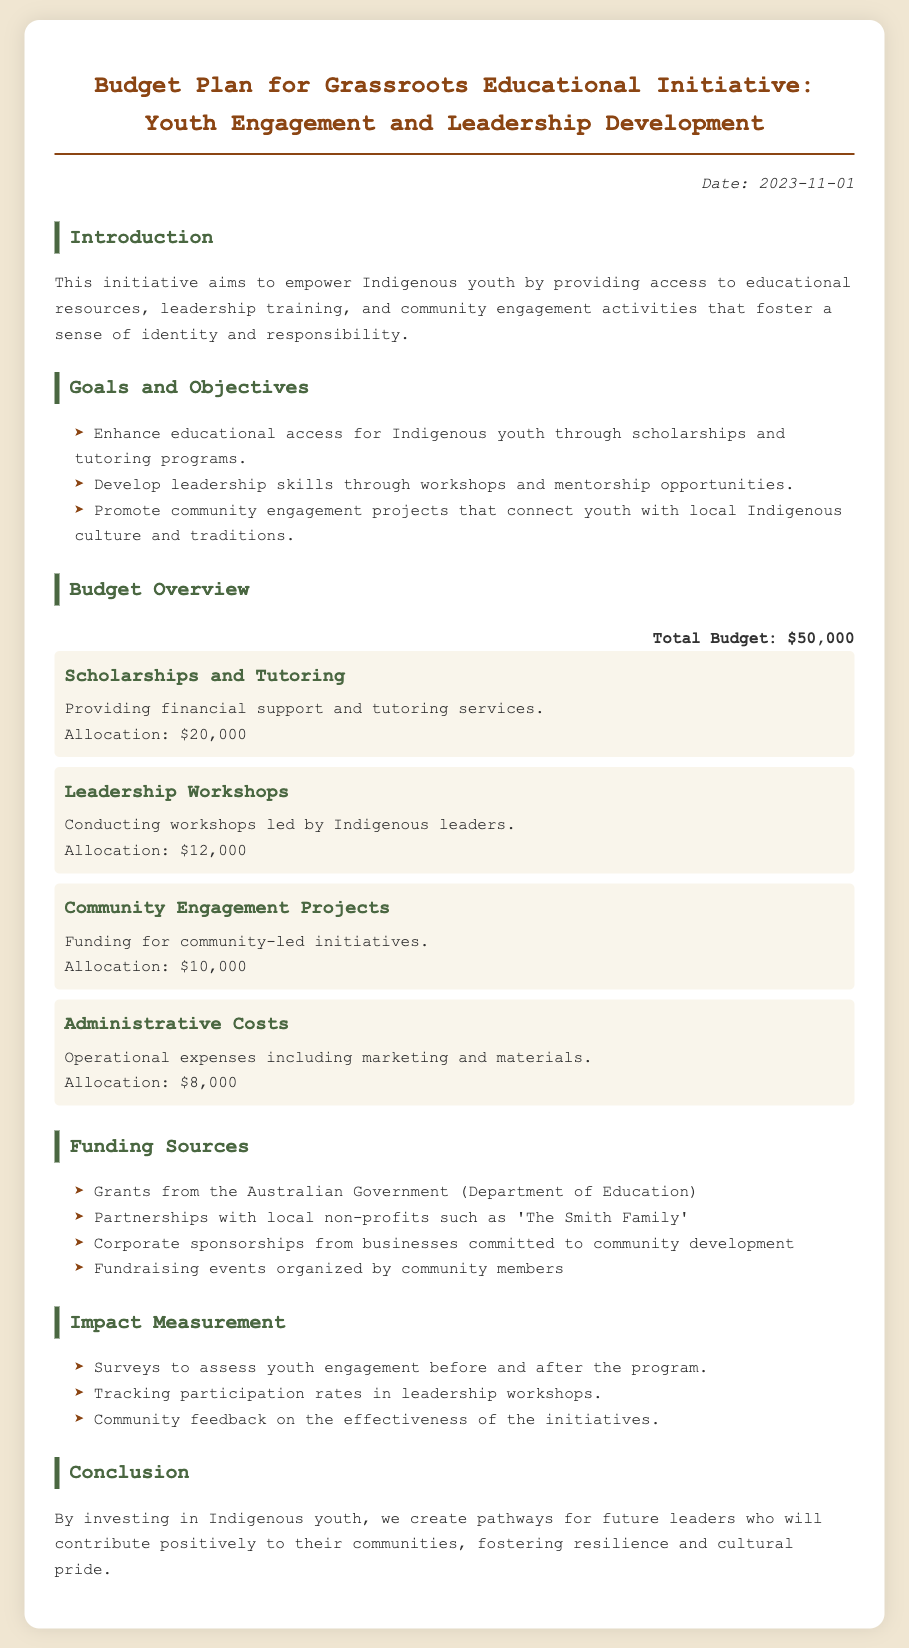What is the total budget for the initiative? The total budget is stated in the budget overview section of the document.
Answer: $50,000 How much is allocated for scholarships and tutoring? The allocation for scholarships and tutoring is detailed in the budget item section.
Answer: $20,000 What is the date of the budget plan document? The date is mentioned at the top of the document under the date section.
Answer: 2023-11-01 Which organization is listed as a funding source? The funding sources are outlined in the funding sources section, mentioning various entities.
Answer: 'The Smith Family' What is one of the goals of the initiative? Goals and objectives are summarized in the goals and objectives section of the document.
Answer: Enhance educational access How much funding is allocated for community engagement projects? The funding amount for community engagement projects is specified in the budget item section.
Answer: $10,000 What method is used to measure the impact of the initiative? The impact measurement methods are outlined in the impact measurement section of the document.
Answer: Surveys Who is leading the leadership workshops? The information is provided in the budget item for leadership workshops, indicating who conducts them.
Answer: Indigenous leaders What is the main purpose of this initiative? The main purpose is summarized in the introduction section of the document.
Answer: Empower Indigenous youth 